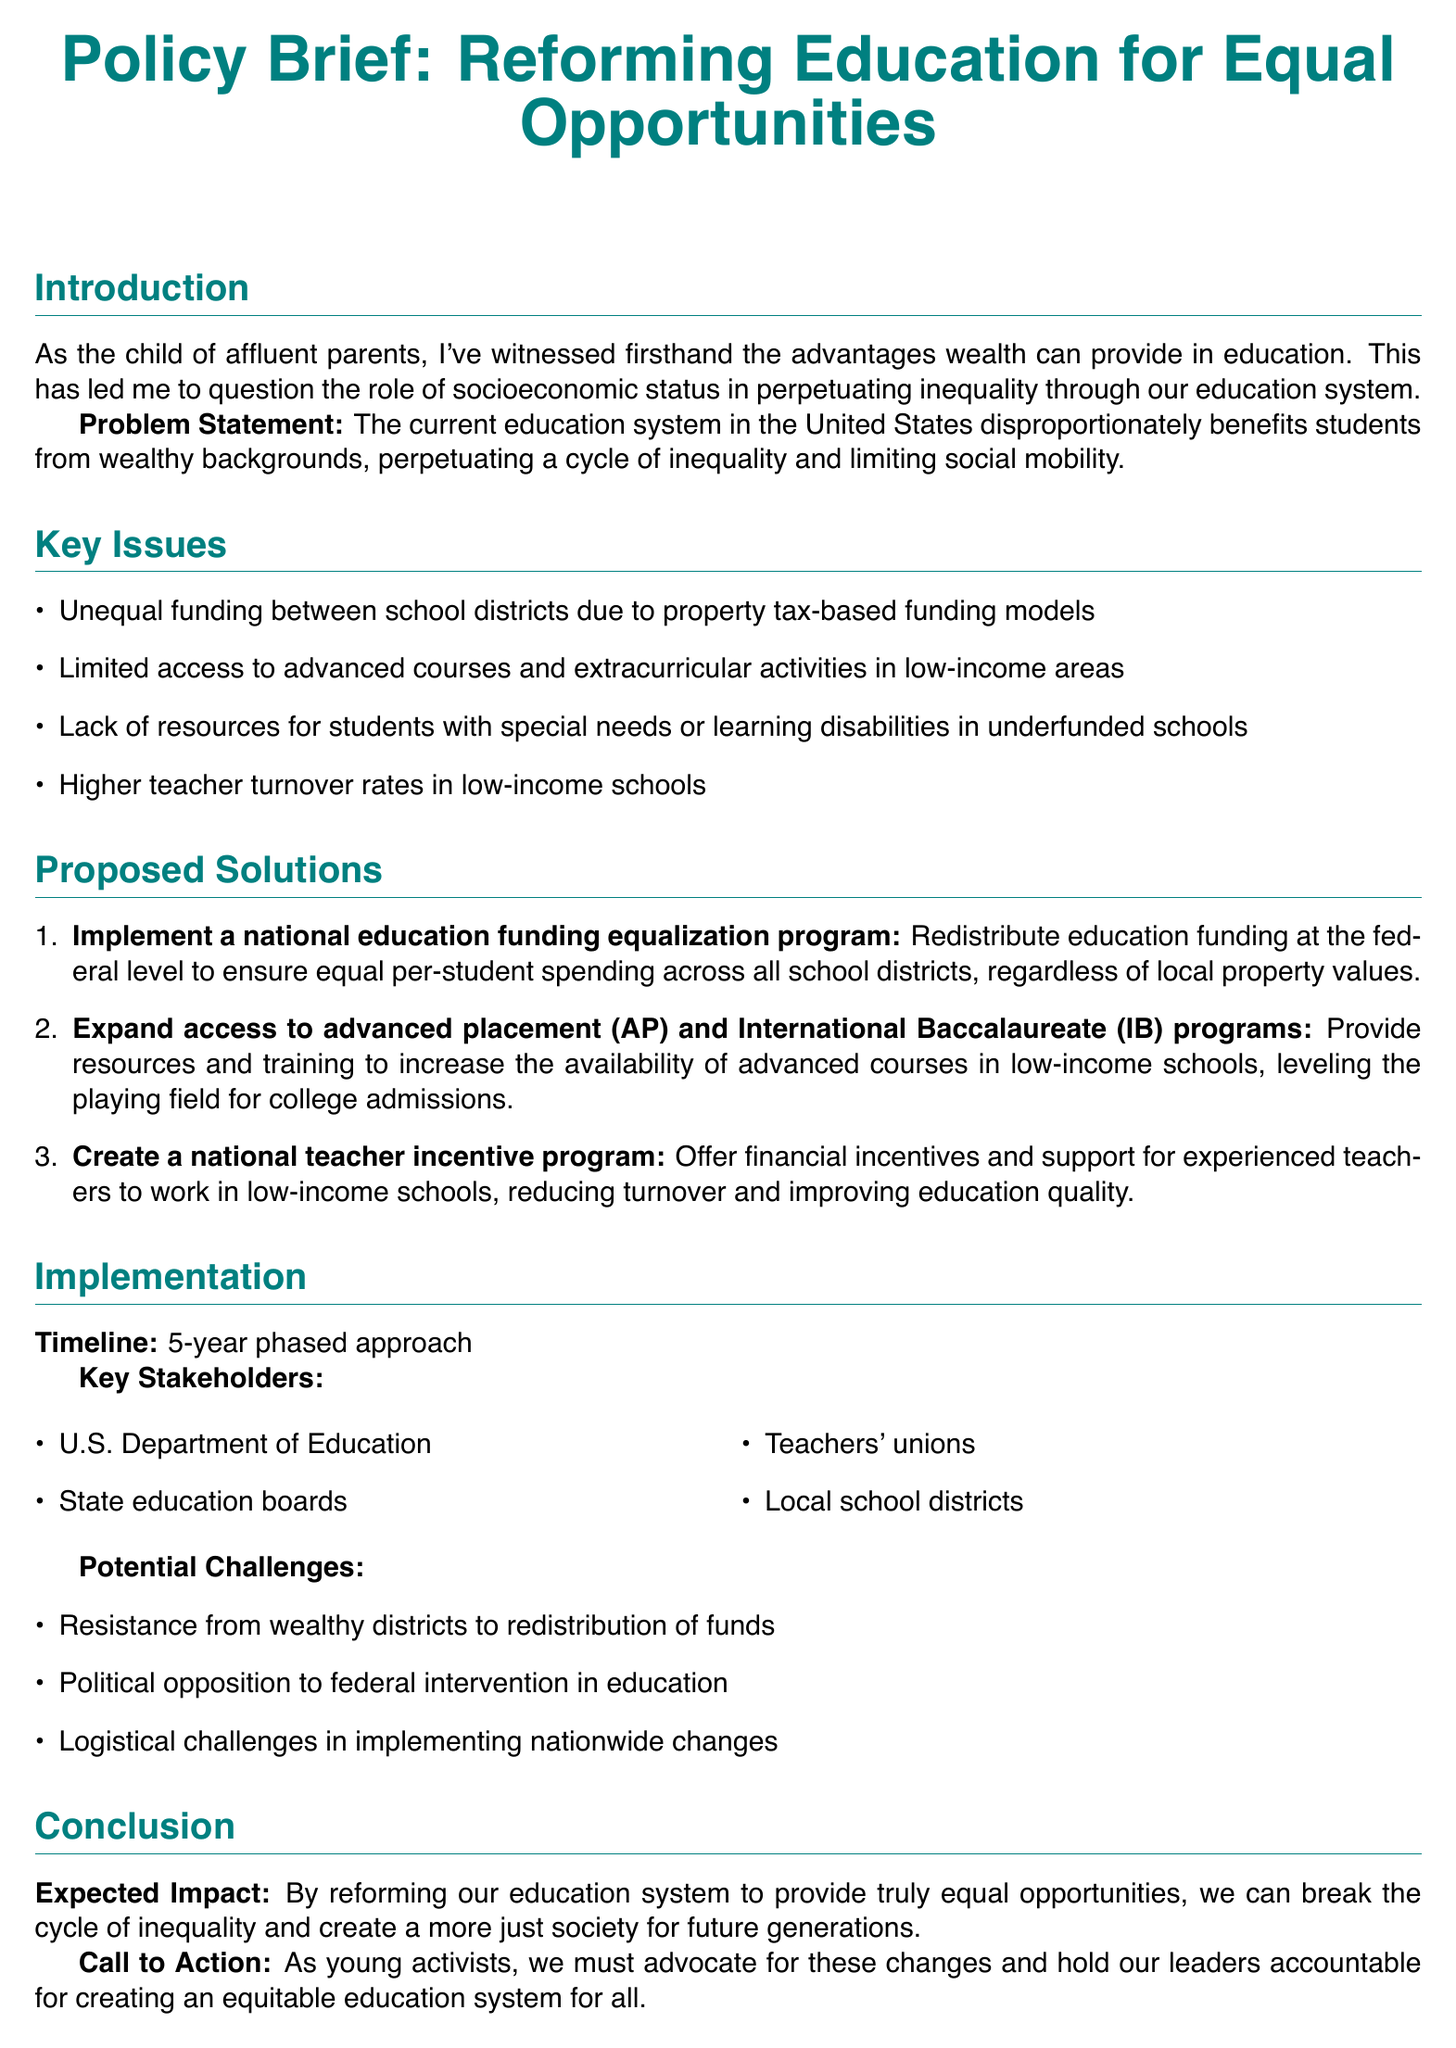What is the title of the policy document? The title of the policy document is clearly stated at the beginning of the document.
Answer: Reforming Education for Equal Opportunities What is the primary problem identified in the document? The problem statement highlights the main issue that the education system benefits students from wealthy backgrounds.
Answer: Disproportionately benefits students from wealthy backgrounds What is one key issue related to school funding? The document lists unequal funding between school districts as a significant issue.
Answer: Unequal funding between school districts How many proposed solutions are listed in the document? The document provides a numbered list of solutions, which can be counted.
Answer: Three What is the timeline for the implementation of the proposed solutions? The document specifies a timeline for implementing the solutions.
Answer: 5-year phased approach Who are considered key stakeholders in the proposed education reform? The document identifies a list of key stakeholders involved in the education reform process.
Answer: U.S. Department of Education, State education boards, Teachers' unions, Local school districts What is a potential challenge mentioned in the document? The potential challenges are explicitly listed in the document, highlighting difficulties to expect.
Answer: Resistance from wealthy districts to redistribution of funds What is the expected impact of the proposed reforms? The conclusion section summarizes the anticipated outcome of the reforms being discussed.
Answer: Break the cycle of inequality and create a more just society 